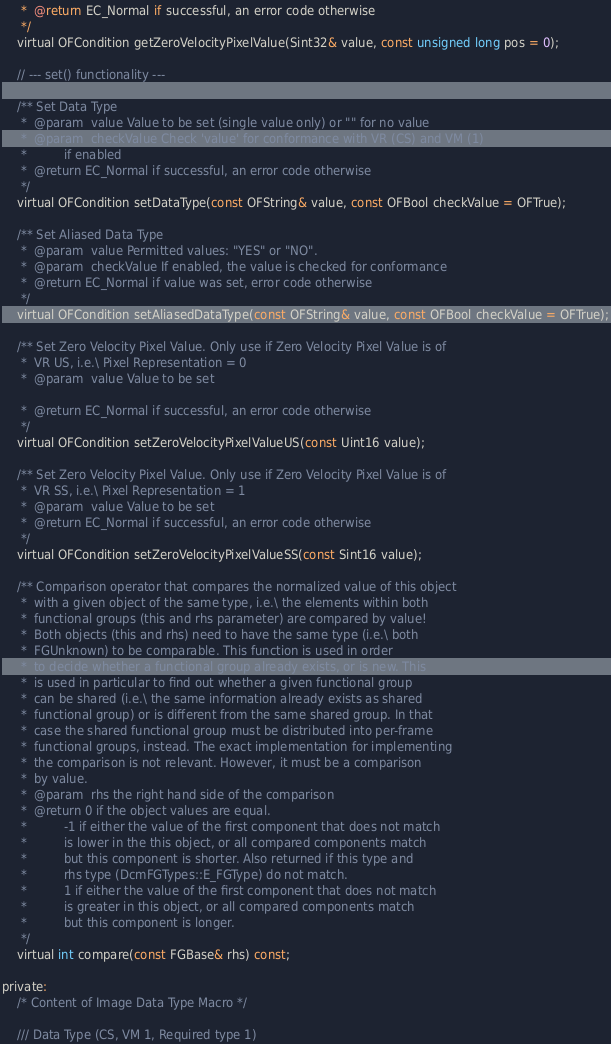Convert code to text. <code><loc_0><loc_0><loc_500><loc_500><_C_>     *  @return EC_Normal if successful, an error code otherwise
     */
    virtual OFCondition getZeroVelocityPixelValue(Sint32& value, const unsigned long pos = 0);

    // --- set() functionality ---

    /** Set Data Type
     *  @param  value Value to be set (single value only) or "" for no value
     *  @param  checkValue Check 'value' for conformance with VR (CS) and VM (1)
     *          if enabled
     *  @return EC_Normal if successful, an error code otherwise
     */
    virtual OFCondition setDataType(const OFString& value, const OFBool checkValue = OFTrue);

    /** Set Aliased Data Type
     *  @param  value Permitted values: "YES" or "NO".
     *  @param  checkValue If enabled, the value is checked for conformance
     *  @return EC_Normal if value was set, error code otherwise
     */
    virtual OFCondition setAliasedDataType(const OFString& value, const OFBool checkValue = OFTrue);

    /** Set Zero Velocity Pixel Value. Only use if Zero Velocity Pixel Value is of
     *  VR US, i.e.\ Pixel Representation = 0
     *  @param  value Value to be set

     *  @return EC_Normal if successful, an error code otherwise
     */
    virtual OFCondition setZeroVelocityPixelValueUS(const Uint16 value);

    /** Set Zero Velocity Pixel Value. Only use if Zero Velocity Pixel Value is of
     *  VR SS, i.e.\ Pixel Representation = 1
     *  @param  value Value to be set
     *  @return EC_Normal if successful, an error code otherwise
     */
    virtual OFCondition setZeroVelocityPixelValueSS(const Sint16 value);

    /** Comparison operator that compares the normalized value of this object
     *  with a given object of the same type, i.e.\ the elements within both
     *  functional groups (this and rhs parameter) are compared by value!
     *  Both objects (this and rhs) need to have the same type (i.e.\ both
     *  FGUnknown) to be comparable. This function is used in order
     *  to decide whether a functional group already exists, or is new. This
     *  is used in particular to find out whether a given functional group
     *  can be shared (i.e.\ the same information already exists as shared
     *  functional group) or is different from the same shared group. In that
     *  case the shared functional group must be distributed into per-frame
     *  functional groups, instead. The exact implementation for implementing
     *  the comparison is not relevant. However, it must be a comparison
     *  by value.
     *  @param  rhs the right hand side of the comparison
     *  @return 0 if the object values are equal.
     *          -1 if either the value of the first component that does not match
     *          is lower in the this object, or all compared components match
     *          but this component is shorter. Also returned if this type and
     *          rhs type (DcmFGTypes::E_FGType) do not match.
     *          1 if either the value of the first component that does not match
     *          is greater in this object, or all compared components match
     *          but this component is longer.
     */
    virtual int compare(const FGBase& rhs) const;

private:
    /* Content of Image Data Type Macro */

    /// Data Type (CS, VM 1, Required type 1)</code> 